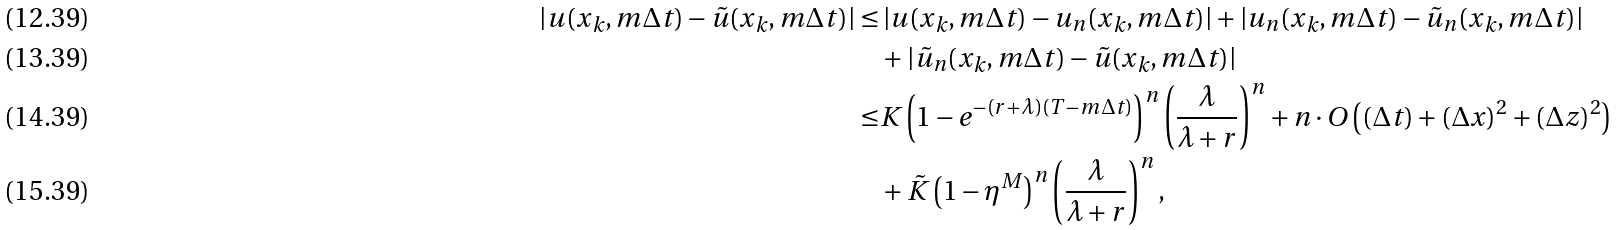<formula> <loc_0><loc_0><loc_500><loc_500>\left | u ( x _ { k } , m \Delta t ) - \tilde { u } ( x _ { k } , m \Delta t ) \right | \leq & \left | u ( x _ { k } , m \Delta t ) - u _ { n } ( x _ { k } , m \Delta t ) \right | + \left | u _ { n } ( x _ { k } , m \Delta t ) - \tilde { u } _ { n } ( x _ { k } , m \Delta t ) \right | \\ & + \left | \tilde { u } _ { n } ( x _ { k } , m \Delta t ) - \tilde { u } ( x _ { k } , m \Delta t ) \right | \\ \leq & K \left ( 1 - e ^ { - ( r + \lambda ) ( T - m \Delta t ) } \right ) ^ { n } \left ( \frac { \lambda } { \lambda + r } \right ) ^ { n } + n \cdot O \left ( ( \Delta t ) + ( \Delta x ) ^ { 2 } + ( \Delta z ) ^ { 2 } \right ) \\ & + \tilde { K } \left ( 1 - \eta ^ { M } \right ) ^ { n } \left ( \frac { \lambda } { \lambda + r } \right ) ^ { n } ,</formula> 